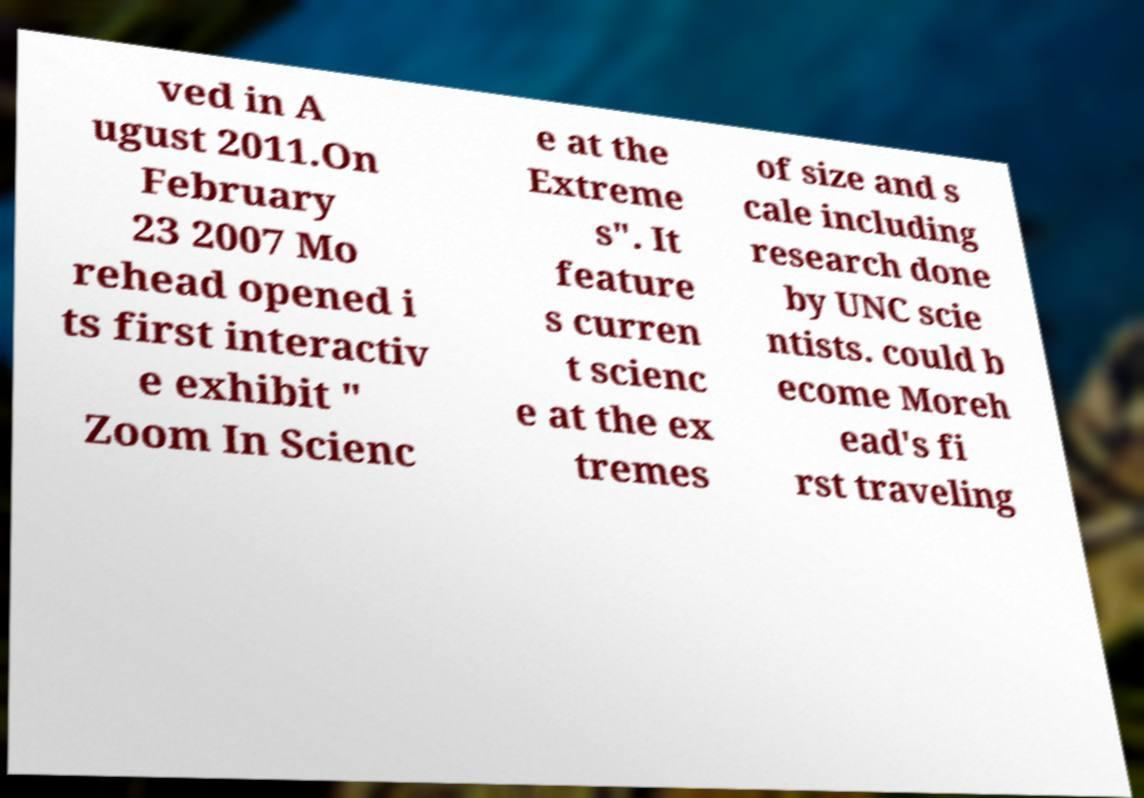For documentation purposes, I need the text within this image transcribed. Could you provide that? ved in A ugust 2011.On February 23 2007 Mo rehead opened i ts first interactiv e exhibit " Zoom In Scienc e at the Extreme s". It feature s curren t scienc e at the ex tremes of size and s cale including research done by UNC scie ntists. could b ecome Moreh ead's fi rst traveling 